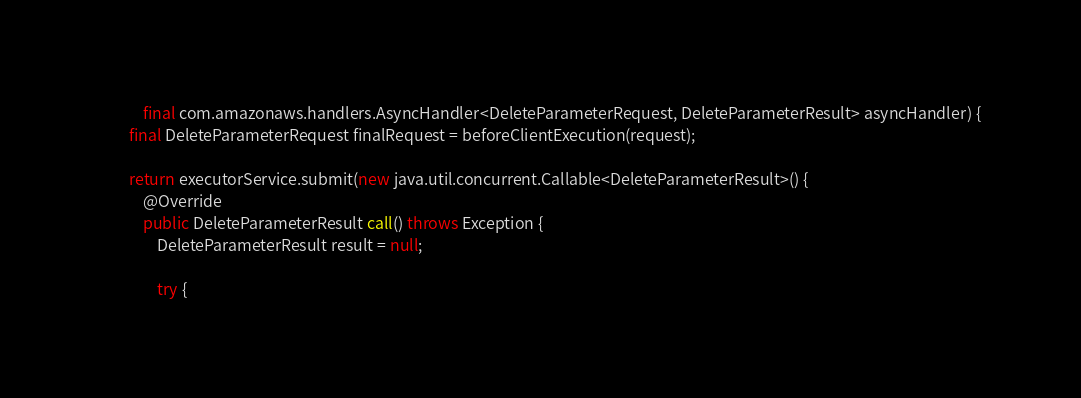Convert code to text. <code><loc_0><loc_0><loc_500><loc_500><_Java_>            final com.amazonaws.handlers.AsyncHandler<DeleteParameterRequest, DeleteParameterResult> asyncHandler) {
        final DeleteParameterRequest finalRequest = beforeClientExecution(request);

        return executorService.submit(new java.util.concurrent.Callable<DeleteParameterResult>() {
            @Override
            public DeleteParameterResult call() throws Exception {
                DeleteParameterResult result = null;

                try {</code> 